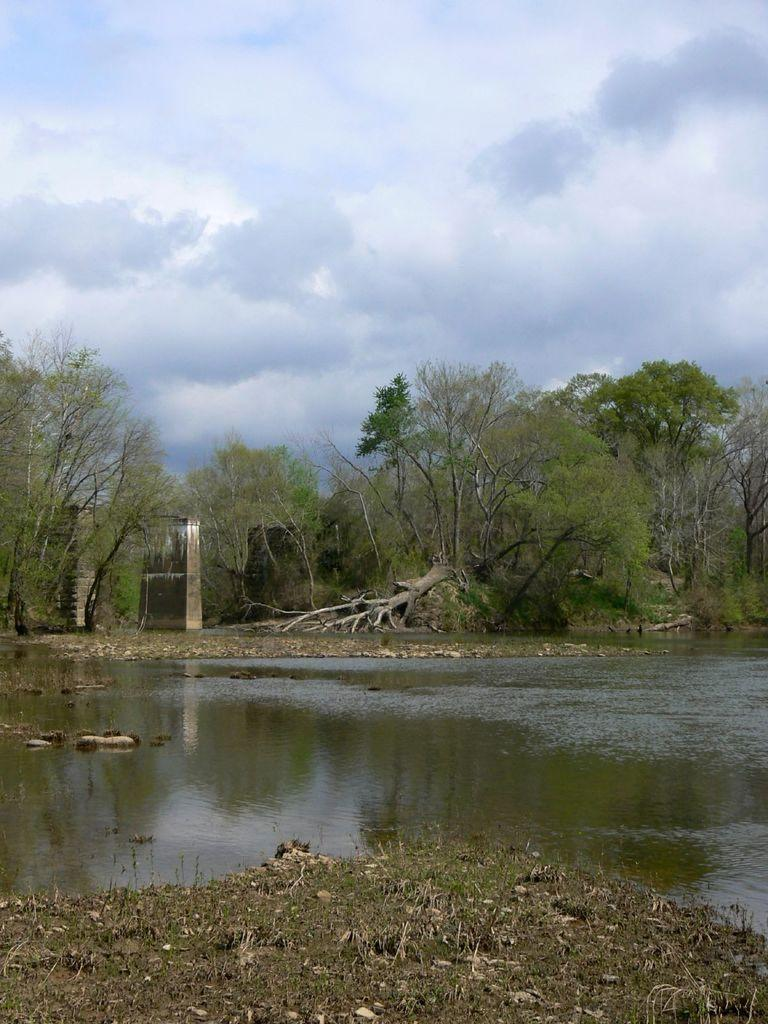Where was the image taken? The image was clicked outside. What is the main subject in the middle of the image? There is water and trees in the middle of the image. What is visible at the top of the image? The sky is visible at the top of the image. What type of plants are causing pain to the person in the image? There is no person present in the image, and no plants are causing pain. 